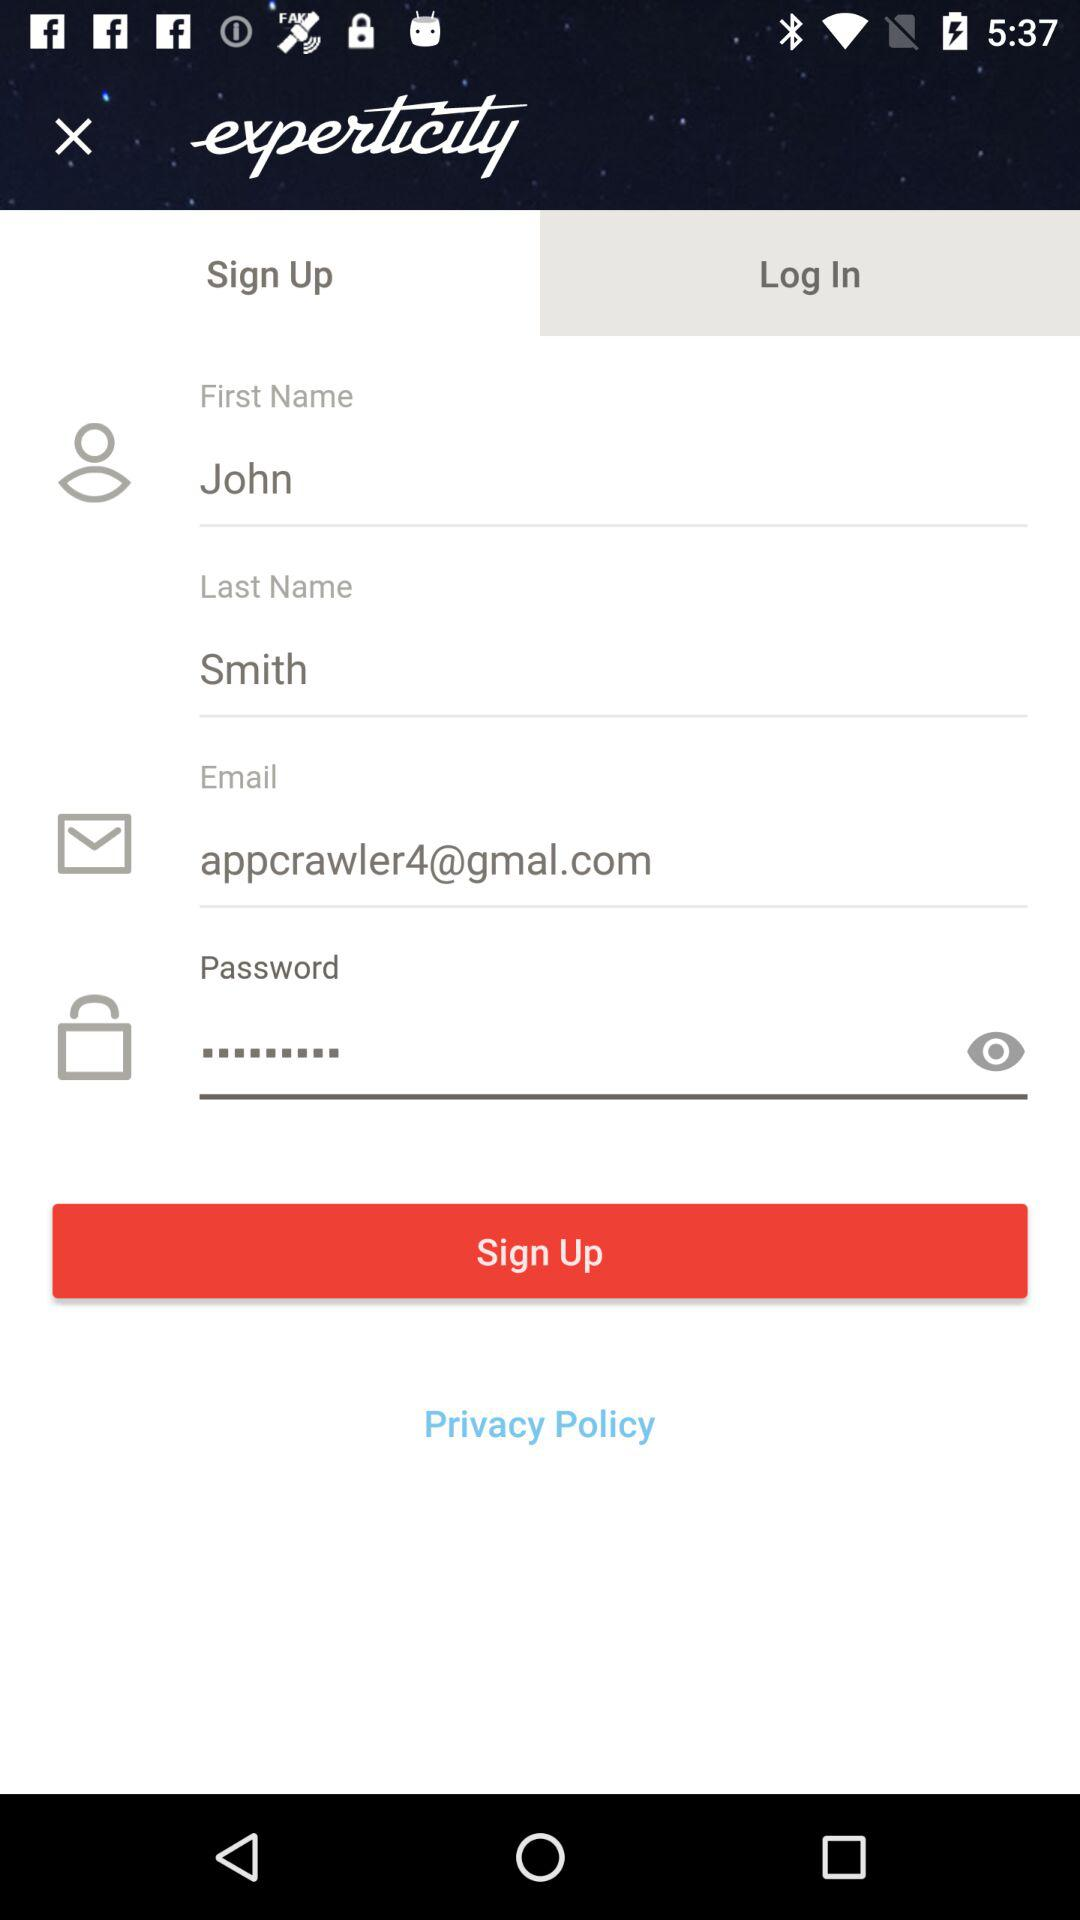How many text inputs are in the sign up form?
Answer the question using a single word or phrase. 4 